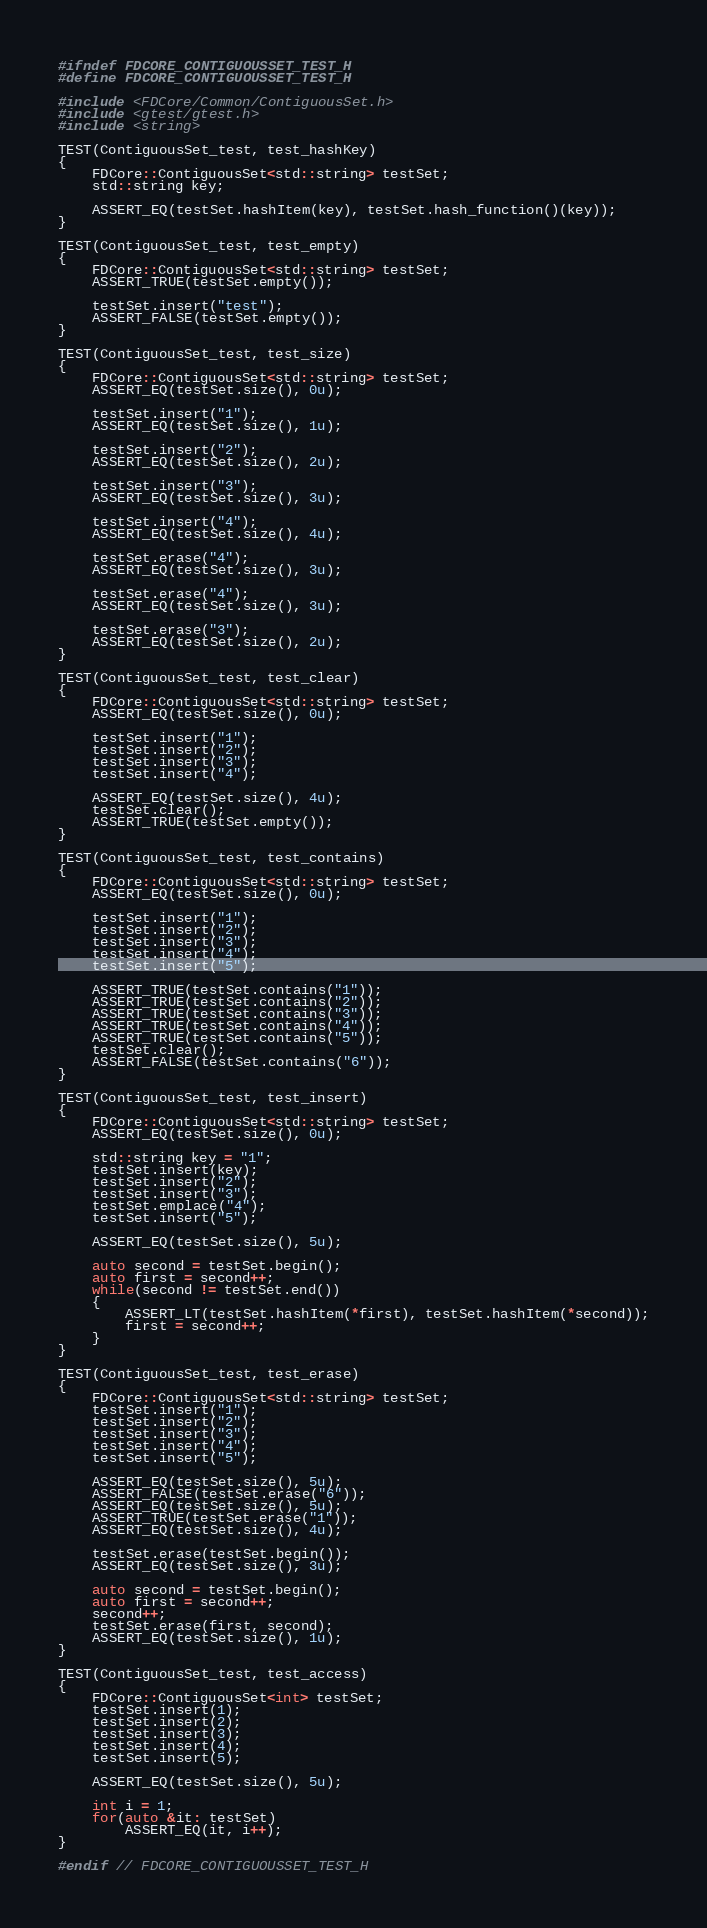Convert code to text. <code><loc_0><loc_0><loc_500><loc_500><_C_>#ifndef FDCORE_CONTIGUOUSSET_TEST_H
#define FDCORE_CONTIGUOUSSET_TEST_H

#include <FDCore/Common/ContiguousSet.h>
#include <gtest/gtest.h>
#include <string>

TEST(ContiguousSet_test, test_hashKey)
{
    FDCore::ContiguousSet<std::string> testSet;
    std::string key;

    ASSERT_EQ(testSet.hashItem(key), testSet.hash_function()(key));
}

TEST(ContiguousSet_test, test_empty)
{
    FDCore::ContiguousSet<std::string> testSet;
    ASSERT_TRUE(testSet.empty());

    testSet.insert("test");
    ASSERT_FALSE(testSet.empty());
}

TEST(ContiguousSet_test, test_size)
{
    FDCore::ContiguousSet<std::string> testSet;
    ASSERT_EQ(testSet.size(), 0u);

    testSet.insert("1");
    ASSERT_EQ(testSet.size(), 1u);

    testSet.insert("2");
    ASSERT_EQ(testSet.size(), 2u);

    testSet.insert("3");
    ASSERT_EQ(testSet.size(), 3u);

    testSet.insert("4");
    ASSERT_EQ(testSet.size(), 4u);

    testSet.erase("4");
    ASSERT_EQ(testSet.size(), 3u);

    testSet.erase("4");
    ASSERT_EQ(testSet.size(), 3u);

    testSet.erase("3");
    ASSERT_EQ(testSet.size(), 2u);
}

TEST(ContiguousSet_test, test_clear)
{
    FDCore::ContiguousSet<std::string> testSet;
    ASSERT_EQ(testSet.size(), 0u);

    testSet.insert("1");
    testSet.insert("2");
    testSet.insert("3");
    testSet.insert("4");

    ASSERT_EQ(testSet.size(), 4u);
    testSet.clear();
    ASSERT_TRUE(testSet.empty());
}

TEST(ContiguousSet_test, test_contains)
{
    FDCore::ContiguousSet<std::string> testSet;
    ASSERT_EQ(testSet.size(), 0u);

    testSet.insert("1");
    testSet.insert("2");
    testSet.insert("3");
    testSet.insert("4");
    testSet.insert("5");

    ASSERT_TRUE(testSet.contains("1"));
    ASSERT_TRUE(testSet.contains("2"));
    ASSERT_TRUE(testSet.contains("3"));
    ASSERT_TRUE(testSet.contains("4"));
    ASSERT_TRUE(testSet.contains("5"));
    testSet.clear();
    ASSERT_FALSE(testSet.contains("6"));
}

TEST(ContiguousSet_test, test_insert)
{
    FDCore::ContiguousSet<std::string> testSet;
    ASSERT_EQ(testSet.size(), 0u);

    std::string key = "1";
    testSet.insert(key);
    testSet.insert("2");
    testSet.insert("3");
    testSet.emplace("4");
    testSet.insert("5");

    ASSERT_EQ(testSet.size(), 5u);

    auto second = testSet.begin();
    auto first = second++;
    while(second != testSet.end())
    {
        ASSERT_LT(testSet.hashItem(*first), testSet.hashItem(*second));
        first = second++;
    }
}

TEST(ContiguousSet_test, test_erase)
{
    FDCore::ContiguousSet<std::string> testSet;
    testSet.insert("1");
    testSet.insert("2");
    testSet.insert("3");
    testSet.insert("4");
    testSet.insert("5");

    ASSERT_EQ(testSet.size(), 5u);
    ASSERT_FALSE(testSet.erase("6"));
    ASSERT_EQ(testSet.size(), 5u);
    ASSERT_TRUE(testSet.erase("1"));
    ASSERT_EQ(testSet.size(), 4u);

    testSet.erase(testSet.begin());
    ASSERT_EQ(testSet.size(), 3u);

    auto second = testSet.begin();
    auto first = second++;
    second++;
    testSet.erase(first, second);
    ASSERT_EQ(testSet.size(), 1u);
}

TEST(ContiguousSet_test, test_access)
{
    FDCore::ContiguousSet<int> testSet;
    testSet.insert(1);
    testSet.insert(2);
    testSet.insert(3);
    testSet.insert(4);
    testSet.insert(5);

    ASSERT_EQ(testSet.size(), 5u);

    int i = 1;
    for(auto &it: testSet)
        ASSERT_EQ(it, i++);
}

#endif // FDCORE_CONTIGUOUSSET_TEST_H</code> 